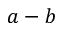<formula> <loc_0><loc_0><loc_500><loc_500>a - b</formula> 